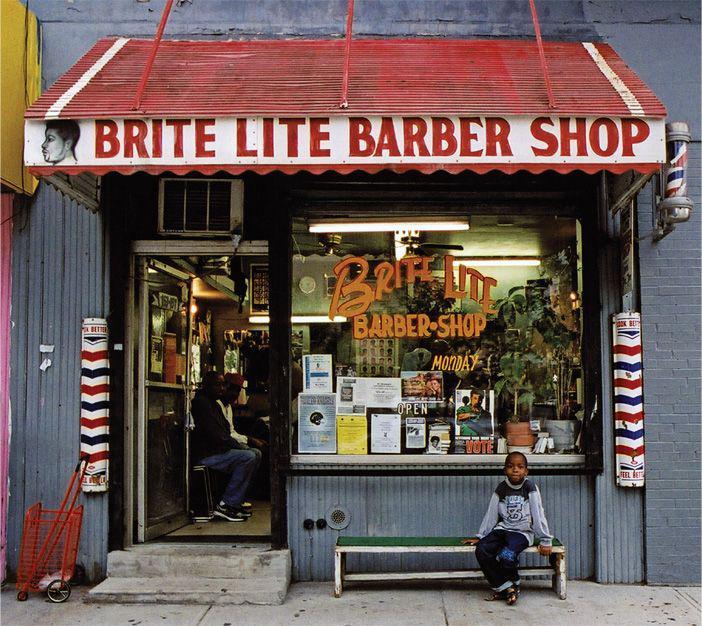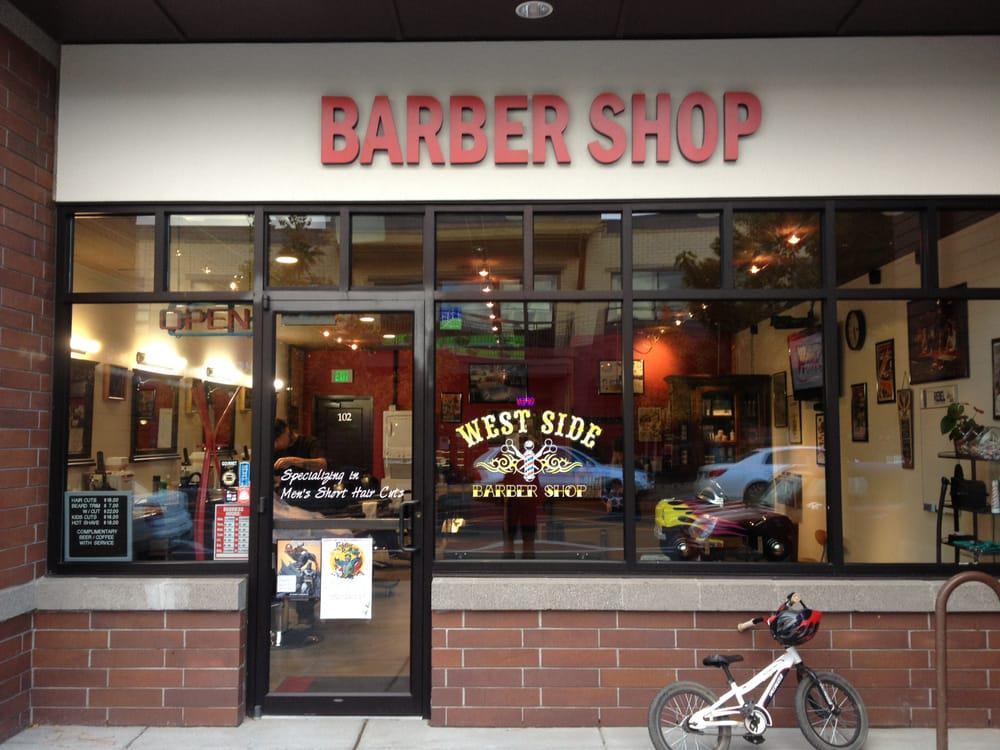The first image is the image on the left, the second image is the image on the right. For the images shown, is this caption "There is at least one barber pole in the image on the left." true? Answer yes or no. Yes. 